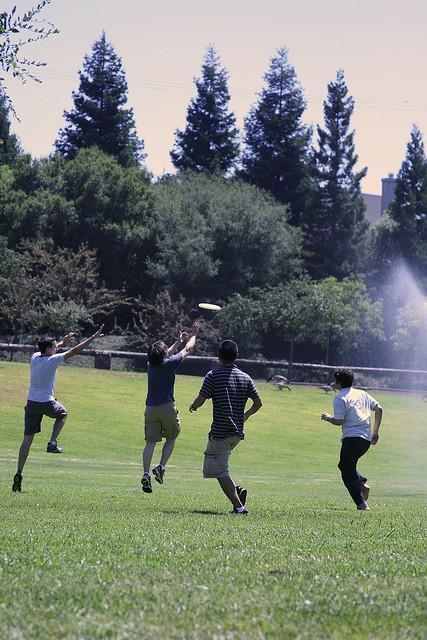How many people are there?
Give a very brief answer. 4. How many people can you see?
Give a very brief answer. 4. 